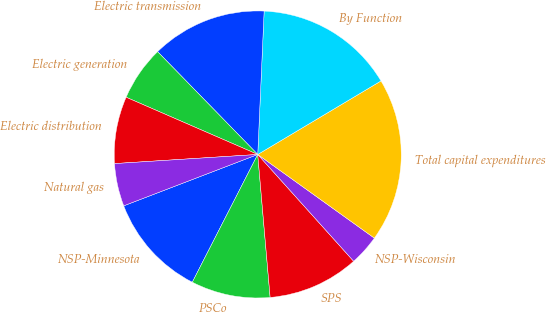Convert chart. <chart><loc_0><loc_0><loc_500><loc_500><pie_chart><fcel>NSP-Minnesota<fcel>PSCo<fcel>SPS<fcel>NSP-Wisconsin<fcel>Total capital expenditures<fcel>By Function<fcel>Electric transmission<fcel>Electric generation<fcel>Electric distribution<fcel>Natural gas<nl><fcel>11.64%<fcel>8.91%<fcel>10.27%<fcel>3.45%<fcel>18.46%<fcel>15.73%<fcel>13.0%<fcel>6.18%<fcel>7.54%<fcel>4.81%<nl></chart> 